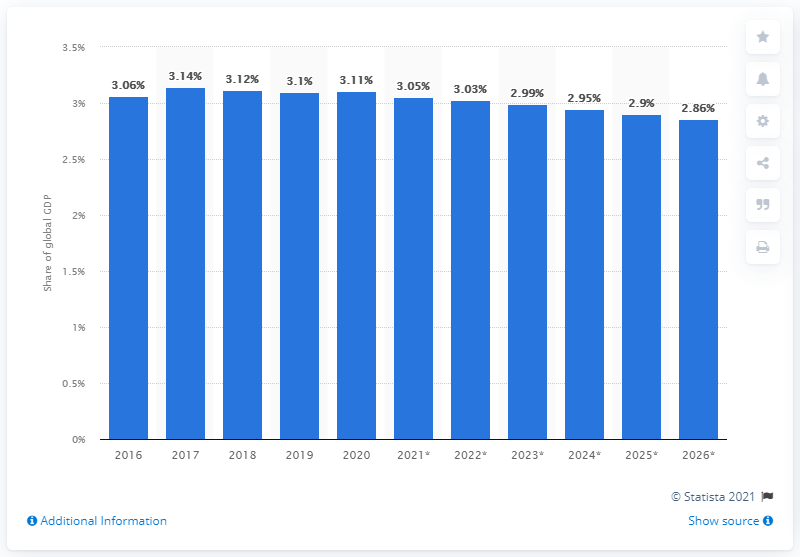Specify some key components in this picture. In 2020, Russia's share of global GDP was 3.11%. 